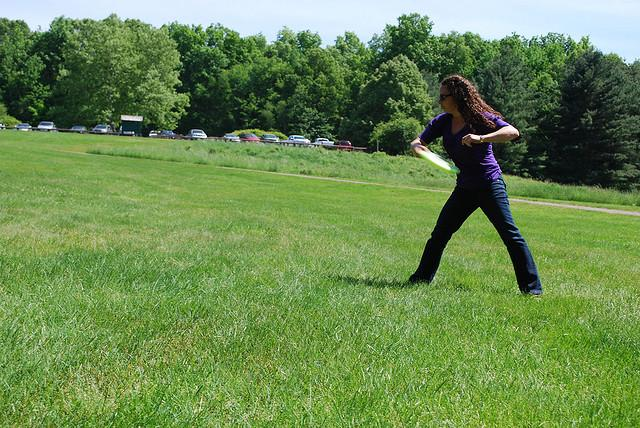What color are her glasses?

Choices:
A) gold
B) red
C) white
D) black black 